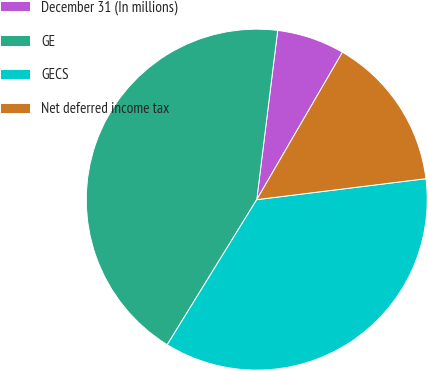Convert chart to OTSL. <chart><loc_0><loc_0><loc_500><loc_500><pie_chart><fcel>December 31 (In millions)<fcel>GE<fcel>GECS<fcel>Net deferred income tax<nl><fcel>6.42%<fcel>43.16%<fcel>35.76%<fcel>14.66%<nl></chart> 